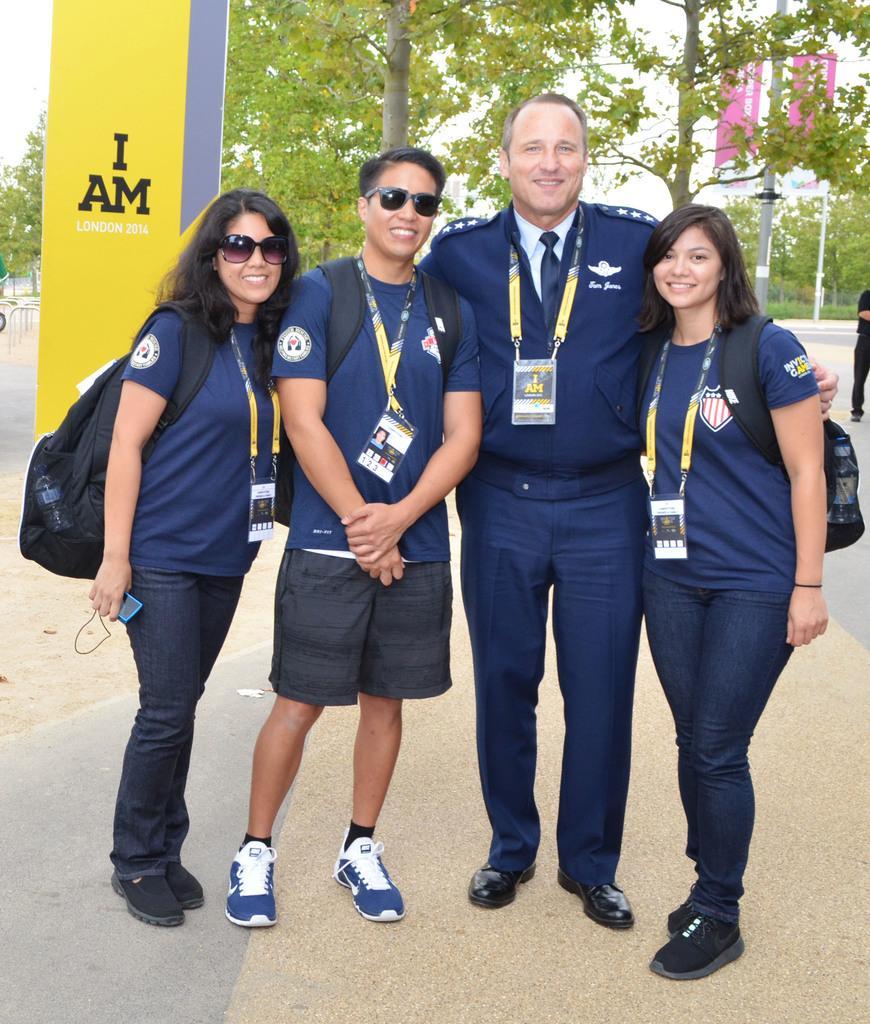In one or two sentences, can you explain what this image depicts? In this picture we can observe four members. All of them are smiling ,wearing blue color t-shirts and yellow color tag in their neck. One of them is wearing blue color shirt. We can observe yellow color poster on the left side. In the background there are trees and a sky. 